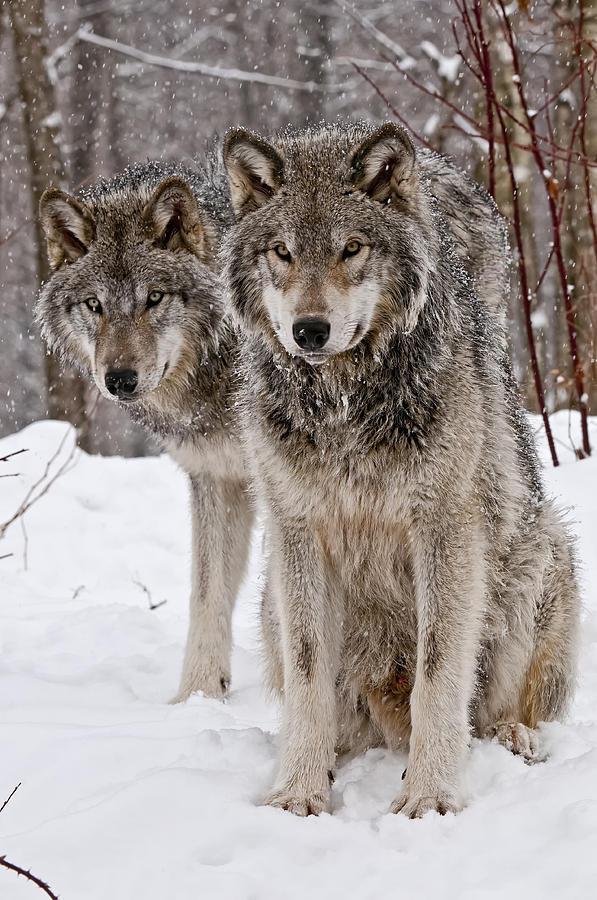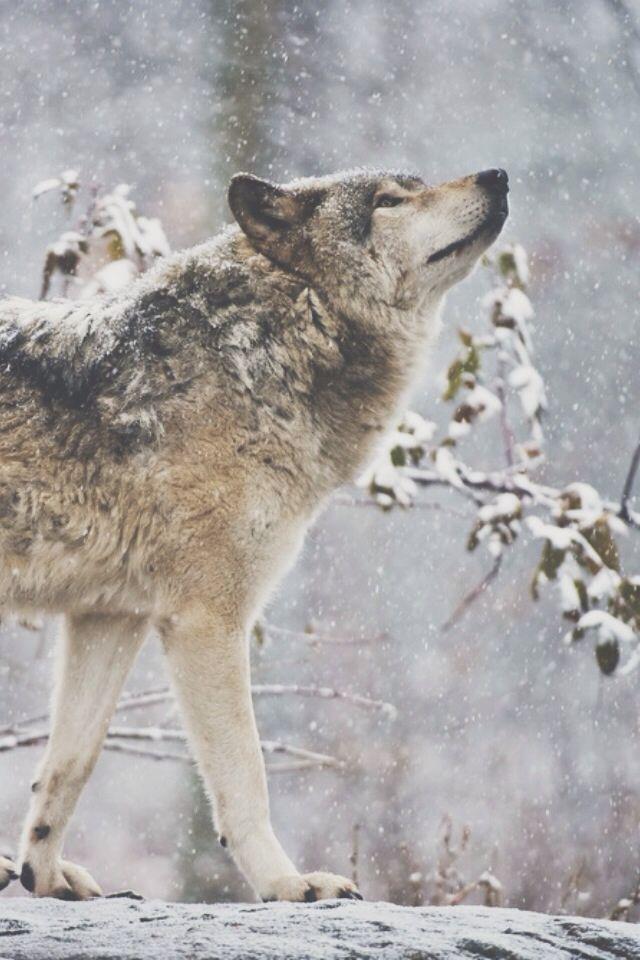The first image is the image on the left, the second image is the image on the right. Assess this claim about the two images: "Each image contains exactly one wolf, and all wolves shown are upright instead of reclining.". Correct or not? Answer yes or no. No. The first image is the image on the left, the second image is the image on the right. Considering the images on both sides, is "At least one wolf is sitting." valid? Answer yes or no. Yes. 